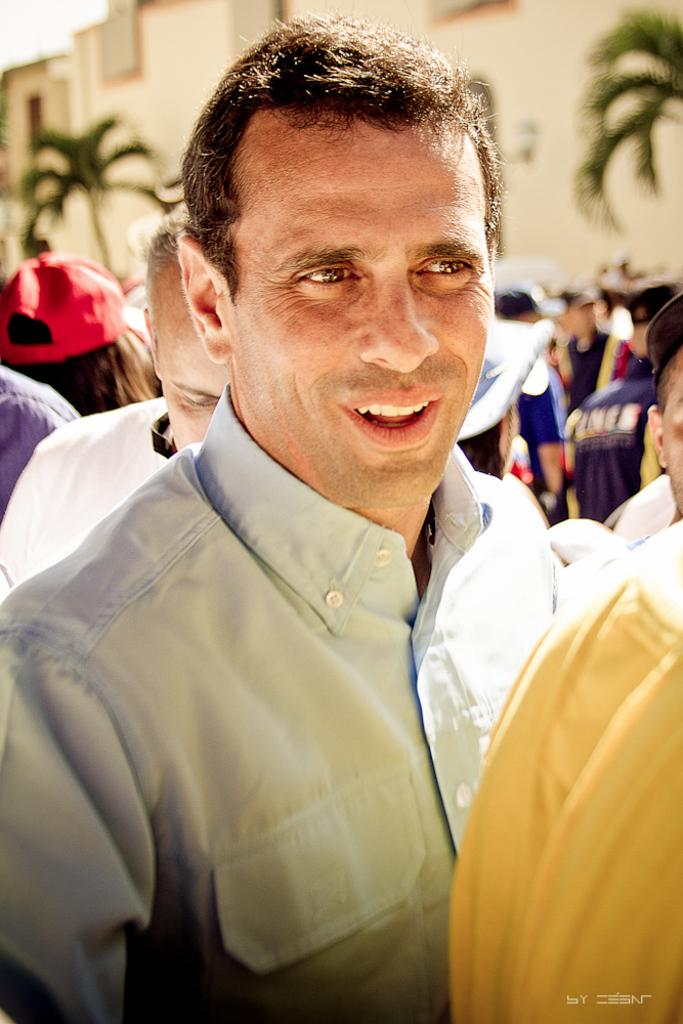What is the expression of the person in the image? The person in the image has a smile. What type of clothing is the person wearing? The person is wearing a shirt. Can you describe the background of the image? There are people, trees, and buildings visible in the background of the image. What letter does the person pull out of their pocket in the image? There is no letter present in the image, and the person is not shown pulling anything out of their pocket. 